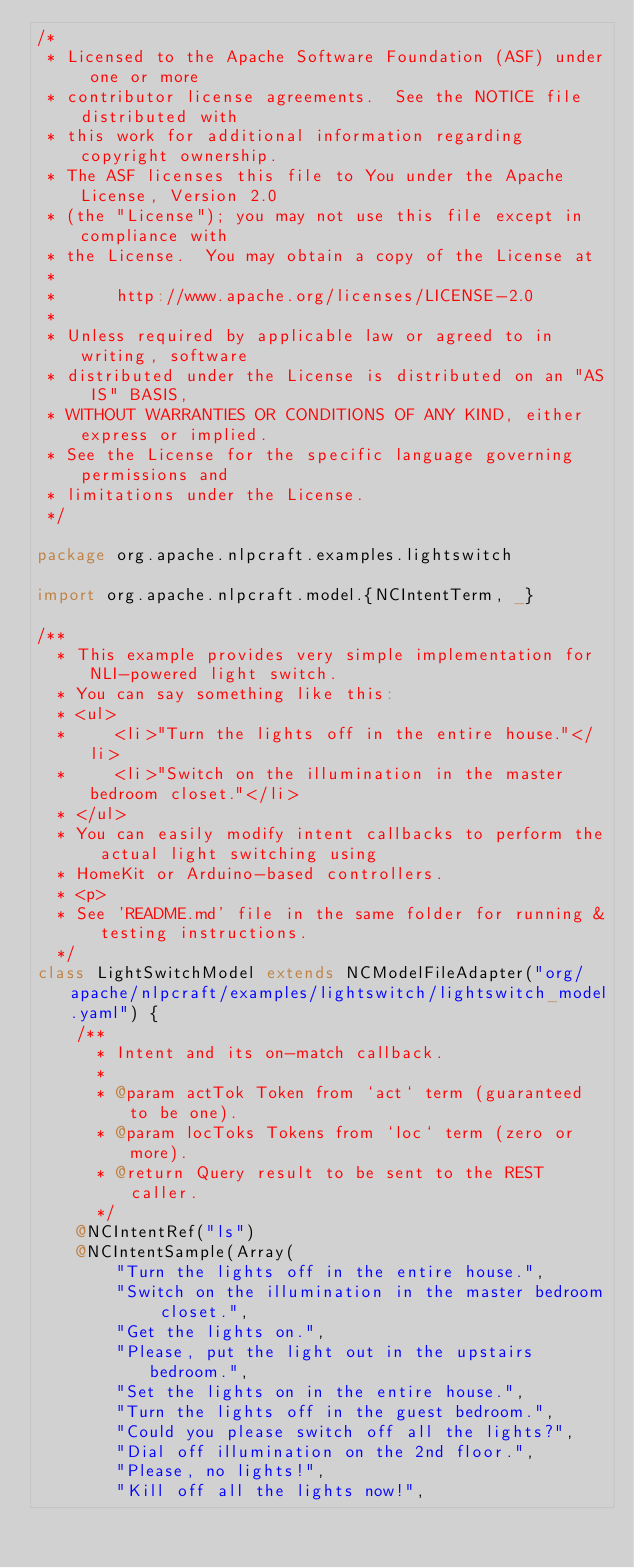<code> <loc_0><loc_0><loc_500><loc_500><_Scala_>/*
 * Licensed to the Apache Software Foundation (ASF) under one or more
 * contributor license agreements.  See the NOTICE file distributed with
 * this work for additional information regarding copyright ownership.
 * The ASF licenses this file to You under the Apache License, Version 2.0
 * (the "License"); you may not use this file except in compliance with
 * the License.  You may obtain a copy of the License at
 *
 *      http://www.apache.org/licenses/LICENSE-2.0
 *
 * Unless required by applicable law or agreed to in writing, software
 * distributed under the License is distributed on an "AS IS" BASIS,
 * WITHOUT WARRANTIES OR CONDITIONS OF ANY KIND, either express or implied.
 * See the License for the specific language governing permissions and
 * limitations under the License.
 */

package org.apache.nlpcraft.examples.lightswitch

import org.apache.nlpcraft.model.{NCIntentTerm, _}

/**
  * This example provides very simple implementation for NLI-powered light switch.
  * You can say something like this:
  * <ul>
  *     <li>"Turn the lights off in the entire house."</li>
  *     <li>"Switch on the illumination in the master bedroom closet."</li>
  * </ul>
  * You can easily modify intent callbacks to perform the actual light switching using
  * HomeKit or Arduino-based controllers.
  * <p>
  * See 'README.md' file in the same folder for running & testing instructions.
  */
class LightSwitchModel extends NCModelFileAdapter("org/apache/nlpcraft/examples/lightswitch/lightswitch_model.yaml") {
    /**
      * Intent and its on-match callback.
      *
      * @param actTok Token from `act` term (guaranteed to be one).
      * @param locToks Tokens from `loc` term (zero or more).
      * @return Query result to be sent to the REST caller.
      */
    @NCIntentRef("ls")
    @NCIntentSample(Array(
        "Turn the lights off in the entire house.",
        "Switch on the illumination in the master bedroom closet.",
        "Get the lights on.",
        "Please, put the light out in the upstairs bedroom.",
        "Set the lights on in the entire house.",
        "Turn the lights off in the guest bedroom.",
        "Could you please switch off all the lights?",
        "Dial off illumination on the 2nd floor.",
        "Please, no lights!",
        "Kill off all the lights now!",</code> 